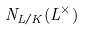<formula> <loc_0><loc_0><loc_500><loc_500>N _ { L / K } ( L ^ { \times } )</formula> 